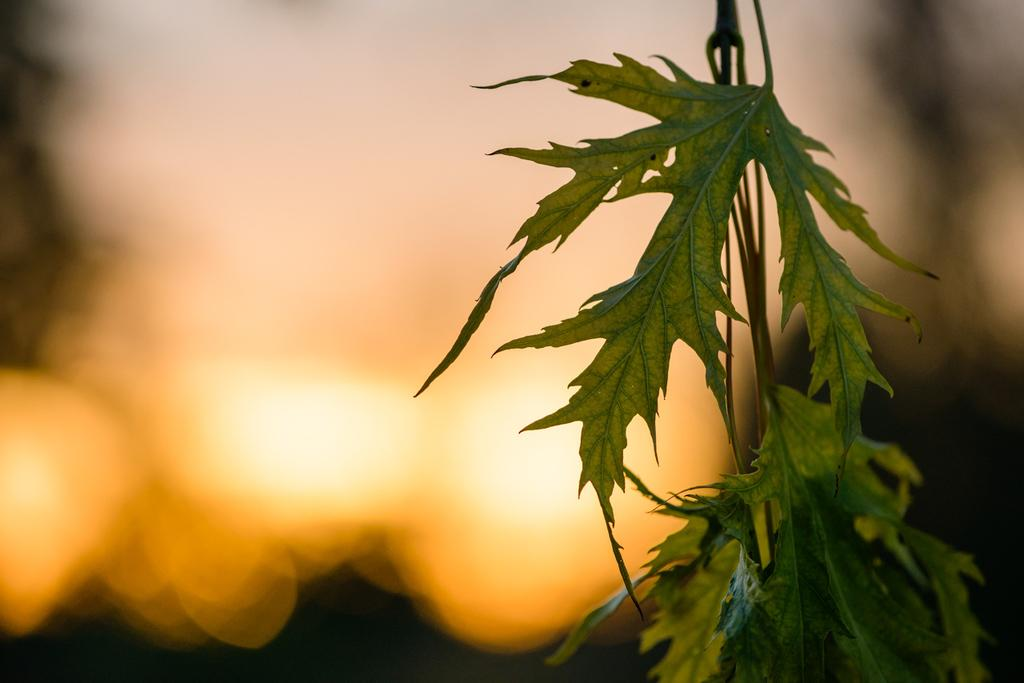What is the main subject of the image? There is a plant in the image. Can you describe the background of the image? The background of the image is blurred. How many sisters are visible in the image? There are no sisters present in the image; it features a plant and a blurred background. What type of crack can be seen in the image? There is no crack visible in the image. 